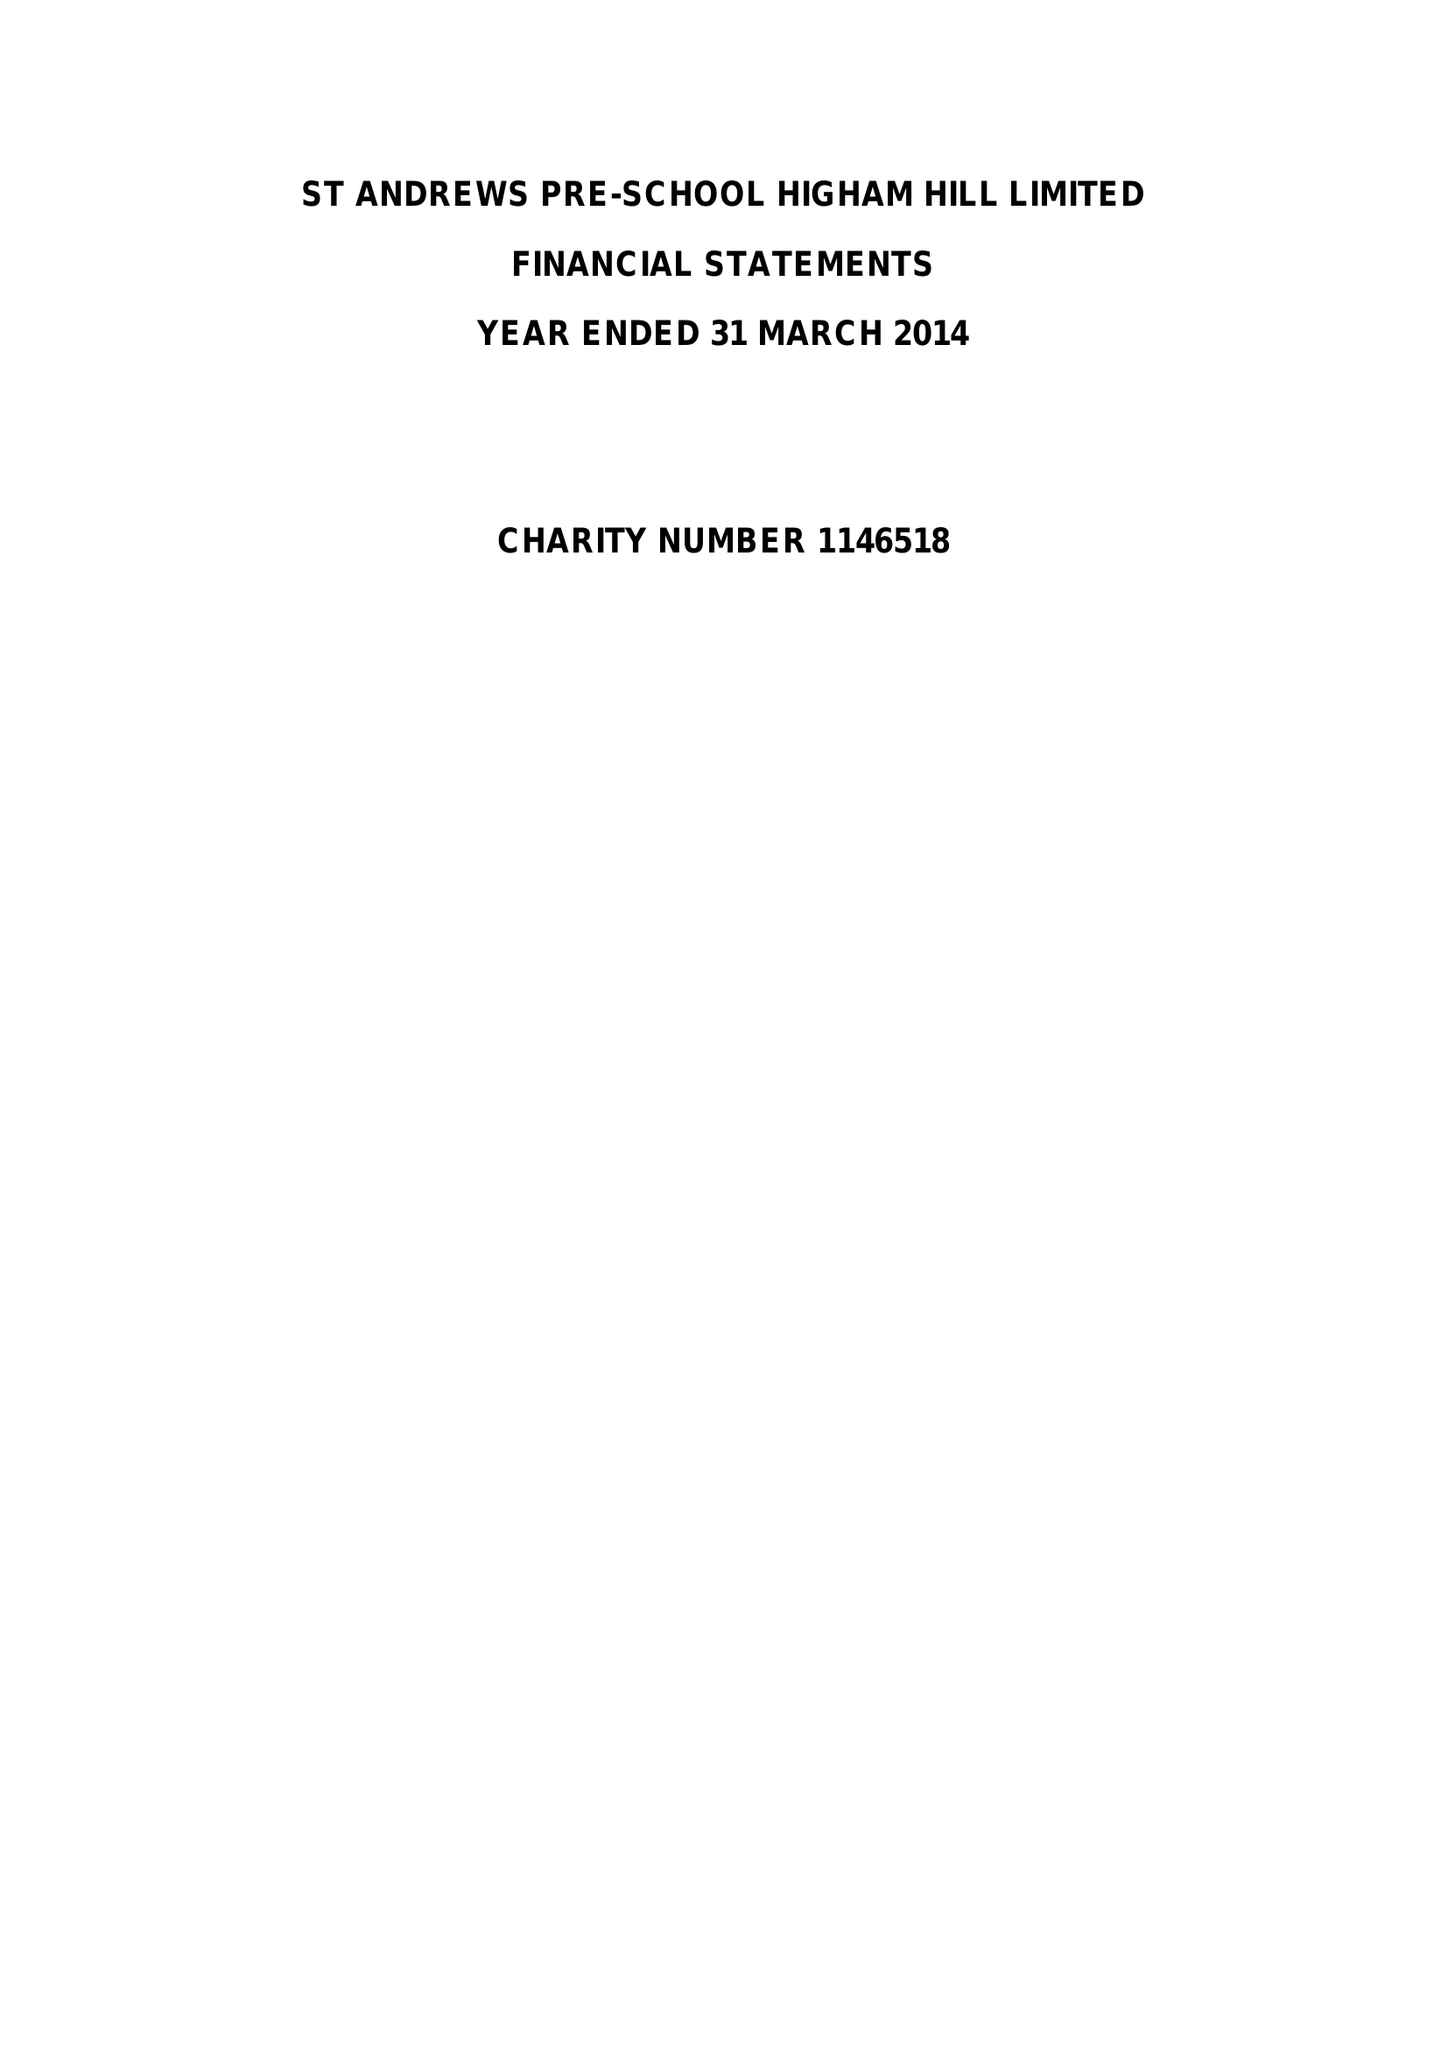What is the value for the spending_annually_in_british_pounds?
Answer the question using a single word or phrase. 96079.00 